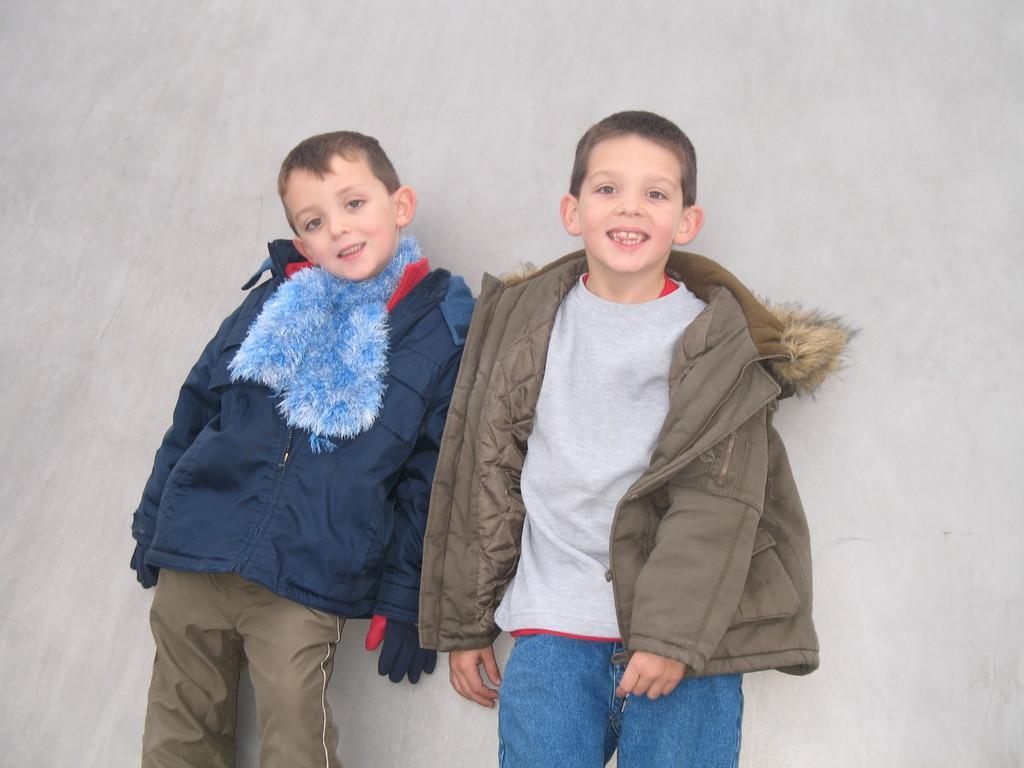In one or two sentences, can you explain what this image depicts? In this image in front two people wearing a smile on their faces. Behind them there is a wall. 